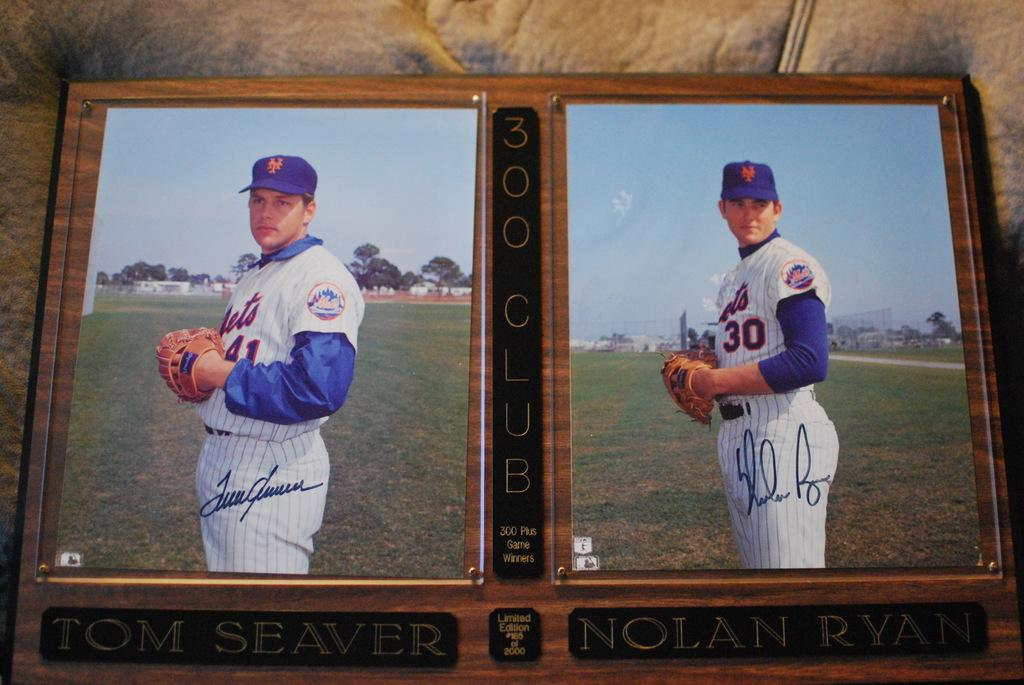Provide a one-sentence caption for the provided image. A 300 Club baseball photo display of Tom Seaver and Nolan Ryan. 